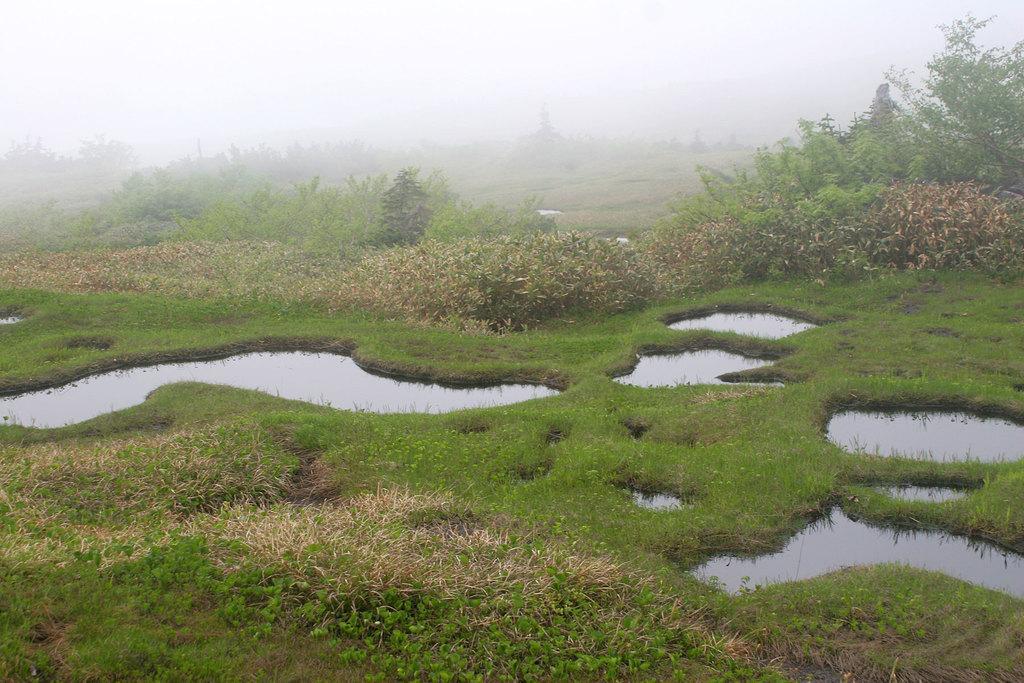How would you summarize this image in a sentence or two? In this image we can see water, grass, group of plants. In the background, we can see a group of trees and the sky. 